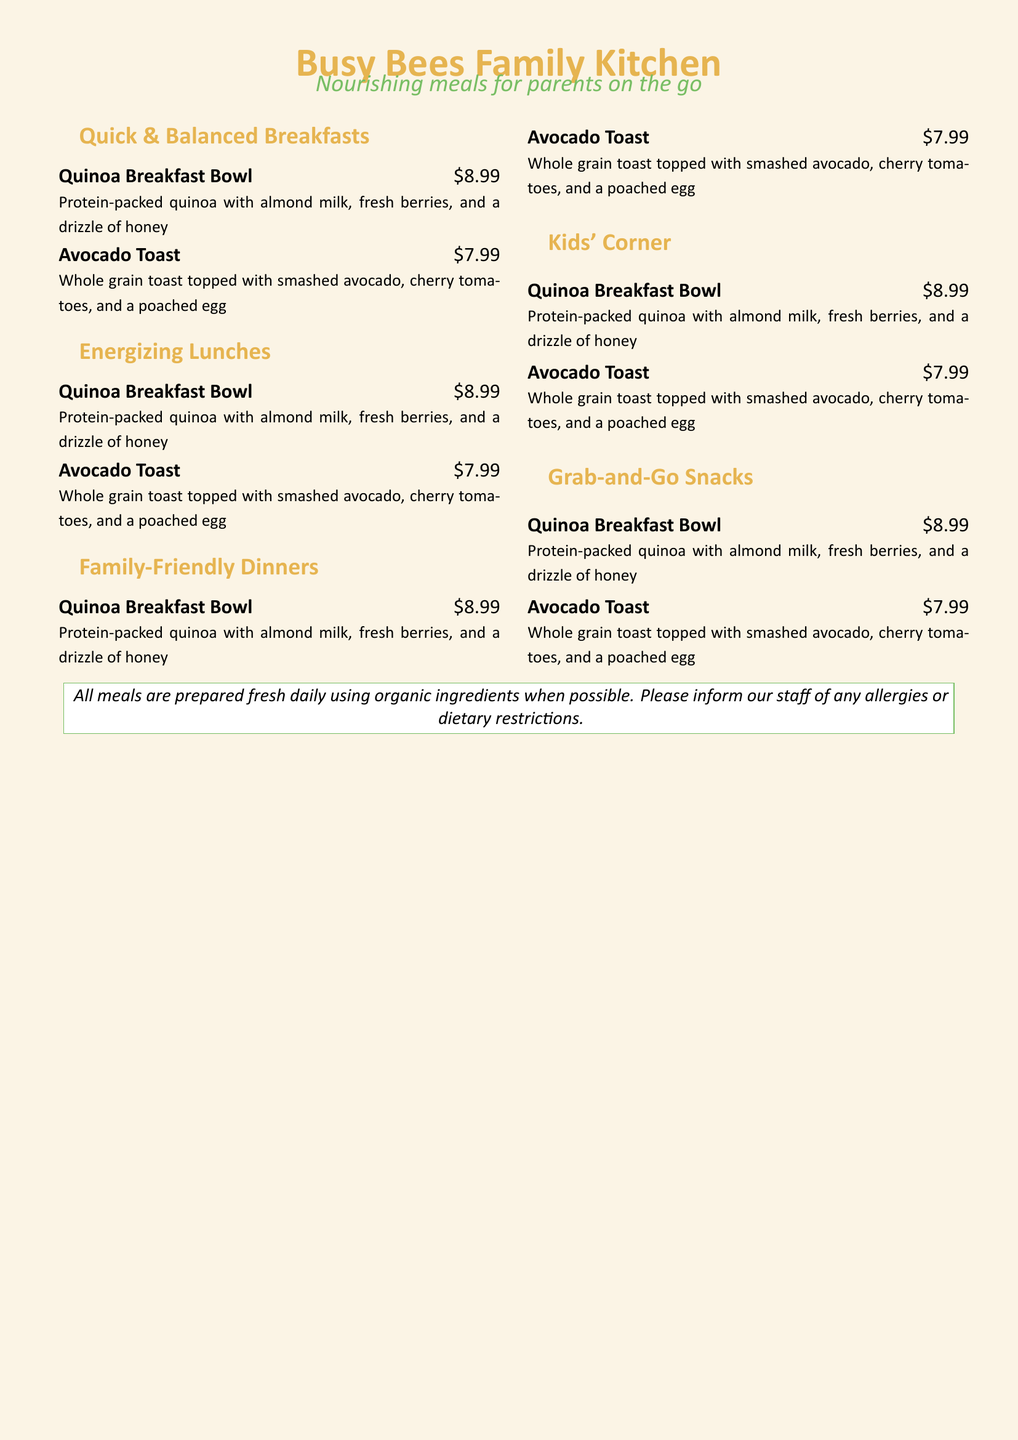what is the name of the restaurant? The name of the restaurant is featured prominently at the top of the menu.
Answer: Busy Bees Family Kitchen what are the operating hours? The document does not provide any information about the operating hours of the restaurant.
Answer: Not available what is the price of the quinoa breakfast bowl? The price of the quinoa breakfast bowl is stated next to the meal description.
Answer: $8.99 what is the main ingredient in the Avocado Toast? The main ingredient in the Avocado Toast is specified next to the meal name in the description.
Answer: smashed avocado how many meal categories are listed on the menu? The number of meal categories is indicated by the sections outlined in the menu.
Answer: 4 what type of bread is used in the Avocado Toast? The type of bread used in the Avocado Toast is mentioned in the description.
Answer: whole grain are the ingredients used in the meals organic? The menu mentions the quality of ingredients used in meal preparation.
Answer: Yes what kind of meal is the Quinoa Breakfast Bowl? The meal type is indicated under the section headings of the menu.
Answer: Breakfast what should customers inform the staff about? The menu includes a note for customers regarding allergies or dietary restrictions.
Answer: allergies or dietary restrictions 